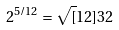<formula> <loc_0><loc_0><loc_500><loc_500>2 ^ { 5 / 1 2 } = \sqrt { [ } 1 2 ] { 3 2 }</formula> 